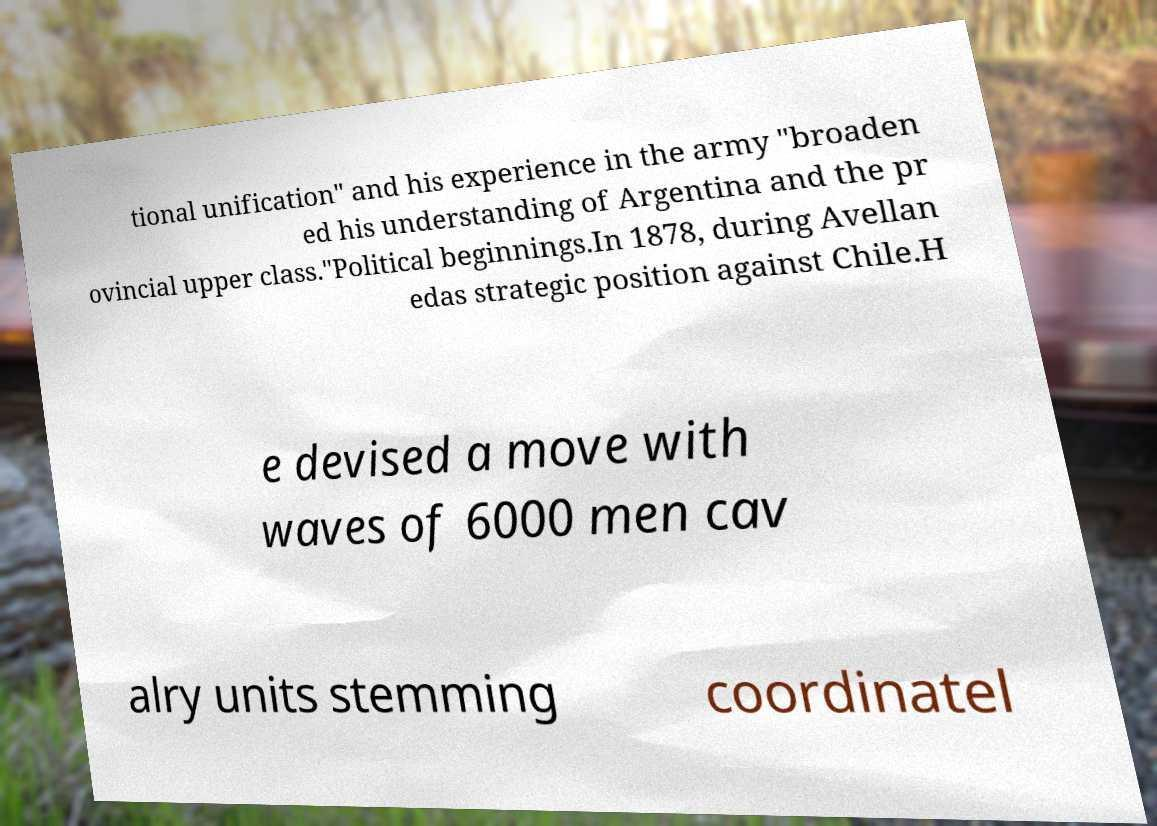For documentation purposes, I need the text within this image transcribed. Could you provide that? tional unification" and his experience in the army "broaden ed his understanding of Argentina and the pr ovincial upper class."Political beginnings.In 1878, during Avellan edas strategic position against Chile.H e devised a move with waves of 6000 men cav alry units stemming coordinatel 